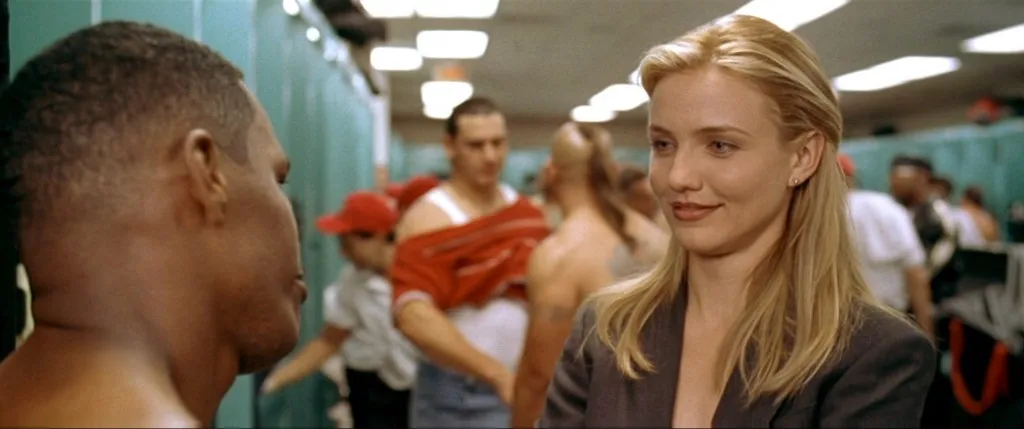What do you think the conversation might be about between the two main individuals in this picture? Given the setting of a locker room and the intense expressions, the conversation likely pertains to a sports-related topic. The woman, in business attire, could be in a managerial or coaching role, discussing strategy, performance, or team dynamics with the athlete. 